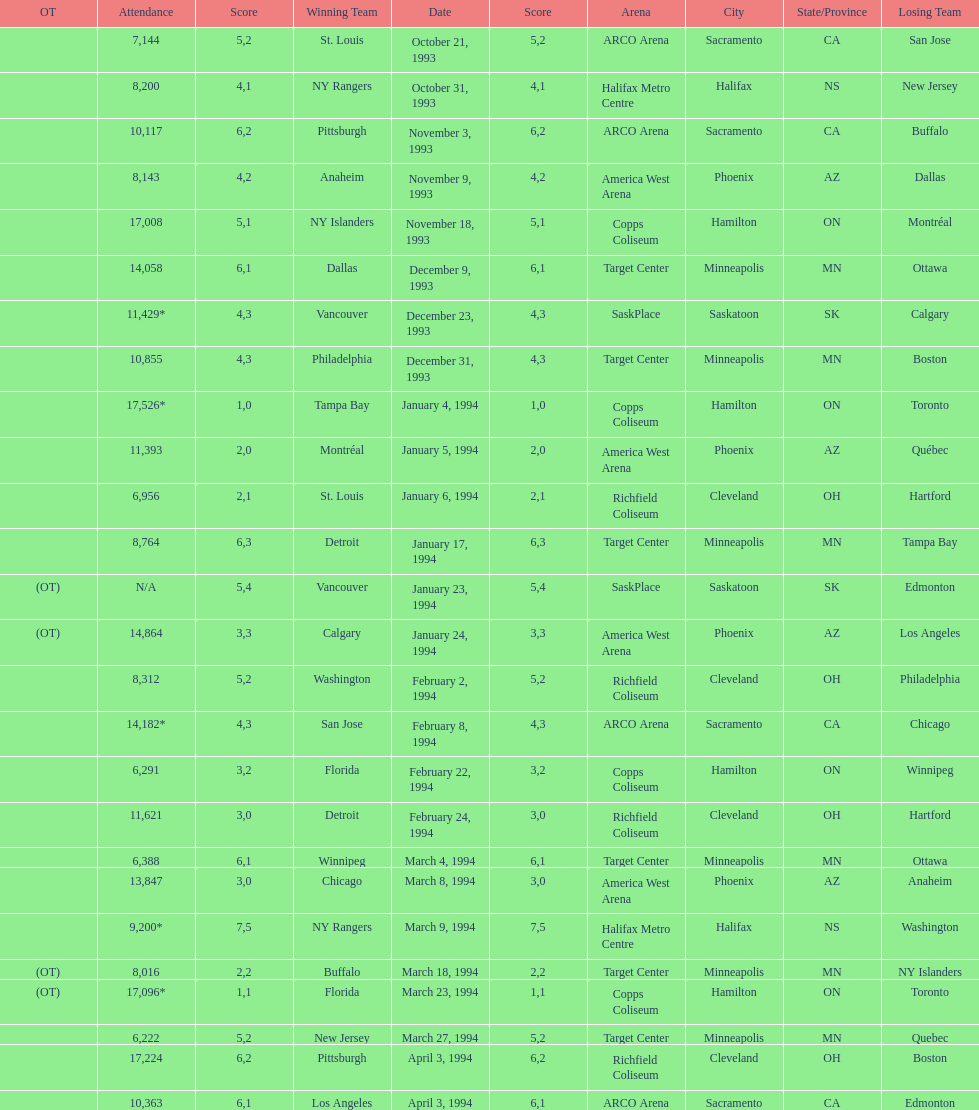Can you give me this table as a dict? {'header': ['OT', 'Attendance', 'Score', 'Winning Team', 'Date', 'Score', 'Arena', 'City', 'State/Province', 'Losing Team'], 'rows': [['', '7,144', '5', 'St. Louis', 'October 21, 1993', '2', 'ARCO Arena', 'Sacramento', 'CA', 'San Jose'], ['', '8,200', '4', 'NY Rangers', 'October 31, 1993', '1', 'Halifax Metro Centre', 'Halifax', 'NS', 'New Jersey'], ['', '10,117', '6', 'Pittsburgh', 'November 3, 1993', '2', 'ARCO Arena', 'Sacramento', 'CA', 'Buffalo'], ['', '8,143', '4', 'Anaheim', 'November 9, 1993', '2', 'America West Arena', 'Phoenix', 'AZ', 'Dallas'], ['', '17,008', '5', 'NY Islanders', 'November 18, 1993', '1', 'Copps Coliseum', 'Hamilton', 'ON', 'Montréal'], ['', '14,058', '6', 'Dallas', 'December 9, 1993', '1', 'Target Center', 'Minneapolis', 'MN', 'Ottawa'], ['', '11,429*', '4', 'Vancouver', 'December 23, 1993', '3', 'SaskPlace', 'Saskatoon', 'SK', 'Calgary'], ['', '10,855', '4', 'Philadelphia', 'December 31, 1993', '3', 'Target Center', 'Minneapolis', 'MN', 'Boston'], ['', '17,526*', '1', 'Tampa Bay', 'January 4, 1994', '0', 'Copps Coliseum', 'Hamilton', 'ON', 'Toronto'], ['', '11,393', '2', 'Montréal', 'January 5, 1994', '0', 'America West Arena', 'Phoenix', 'AZ', 'Québec'], ['', '6,956', '2', 'St. Louis', 'January 6, 1994', '1', 'Richfield Coliseum', 'Cleveland', 'OH', 'Hartford'], ['', '8,764', '6', 'Detroit', 'January 17, 1994', '3', 'Target Center', 'Minneapolis', 'MN', 'Tampa Bay'], ['(OT)', 'N/A', '5', 'Vancouver', 'January 23, 1994', '4', 'SaskPlace', 'Saskatoon', 'SK', 'Edmonton'], ['(OT)', '14,864', '3', 'Calgary', 'January 24, 1994', '3', 'America West Arena', 'Phoenix', 'AZ', 'Los Angeles'], ['', '8,312', '5', 'Washington', 'February 2, 1994', '2', 'Richfield Coliseum', 'Cleveland', 'OH', 'Philadelphia'], ['', '14,182*', '4', 'San Jose', 'February 8, 1994', '3', 'ARCO Arena', 'Sacramento', 'CA', 'Chicago'], ['', '6,291', '3', 'Florida', 'February 22, 1994', '2', 'Copps Coliseum', 'Hamilton', 'ON', 'Winnipeg'], ['', '11,621', '3', 'Detroit', 'February 24, 1994', '0', 'Richfield Coliseum', 'Cleveland', 'OH', 'Hartford'], ['', '6,388', '6', 'Winnipeg', 'March 4, 1994', '1', 'Target Center', 'Minneapolis', 'MN', 'Ottawa'], ['', '13,847', '3', 'Chicago', 'March 8, 1994', '0', 'America West Arena', 'Phoenix', 'AZ', 'Anaheim'], ['', '9,200*', '7', 'NY Rangers', 'March 9, 1994', '5', 'Halifax Metro Centre', 'Halifax', 'NS', 'Washington'], ['(OT)', '8,016', '2', 'Buffalo', 'March 18, 1994', '2', 'Target Center', 'Minneapolis', 'MN', 'NY Islanders'], ['(OT)', '17,096*', '1', 'Florida', 'March 23, 1994', '1', 'Copps Coliseum', 'Hamilton', 'ON', 'Toronto'], ['', '6,222', '5', 'New Jersey', 'March 27, 1994', '2', 'Target Center', 'Minneapolis', 'MN', 'Quebec'], ['', '17,224', '6', 'Pittsburgh', 'April 3, 1994', '2', 'Richfield Coliseum', 'Cleveland', 'OH', 'Boston'], ['', '10,363', '6', 'Los Angeles', 'April 3, 1994', '1', 'ARCO Arena', 'Sacramento', 'CA', 'Edmonton']]} In how many neutral site games was overtime (ot) experienced? 4. 